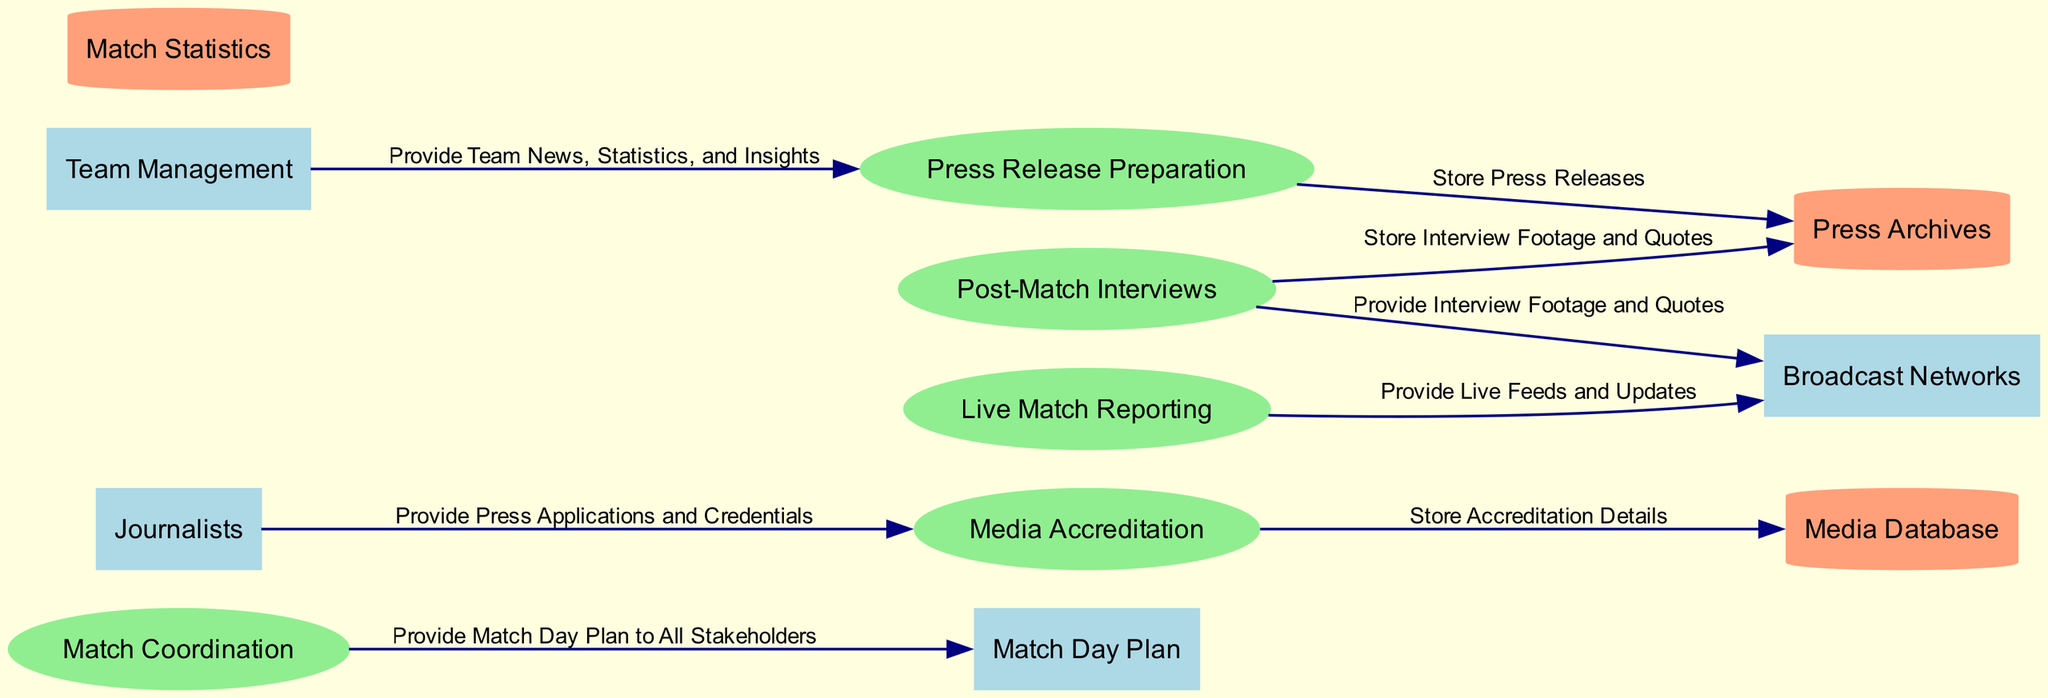What is the first process listed in the diagram? The first process in the processes section is "Match Coordination". The diagram lists processes in a specific order, and "Match Coordination" appears at the top.
Answer: Match Coordination How many data stores are included in the diagram? The diagram includes three data stores as listed in the data section. These are "Media Database," "Press Archives," and "Match Statistics." Counting them gives us a total of three.
Answer: 3 What type of information do journalists provide to the Media Accreditation process? Journalists provide "Press Applications" and "Credentials" to the Media Accreditation process. This is indicated by the data flow from the "Journalists" entity to the "Media Accreditation" process.
Answer: Press Applications and Credentials Which entity requests live feeds for broadcast? The "Broadcast Networks" entity is responsible for requesting live feeds for broadcast. This is indicated by the data flow from "Live Match Reporting" to "Broadcast Networks."
Answer: Broadcast Networks What is the output of the "Press Release Preparation" process? The output of the "Press Release Preparation" process is "Press Releases." This is specified in the output section of the process.
Answer: Press Releases Which process handles the storage of accreditation details? The "Media Accreditation" process handles the storage of accreditation details, as it is linked to the "Media Database" through a data flow that describes this action.
Answer: Media Accreditation What are the two outputs from the "Post-Match Interviews" process? The "Post-Match Interviews" process outputs "Interview Footage" and "Quotes." This is shown clearly under the outputs of the process in the diagram.
Answer: Interview Footage and Quotes What do "Team Management" provide to the "Press Release Preparation"? "Team Management" provides "Team News," "Player Statistics," and "Match Insights" to the "Press Release Preparation" process. This is detailed in the inputs section of the process.
Answer: Team News, Player Statistics, and Match Insights How does the "Match Coordination" process affect all stakeholders? The "Match Coordination" process provides a "Match Day Plan" to all stakeholders, which is a key output indicating its influence on the broader context of the match coverage.
Answer: Match Day Plan 